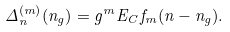Convert formula to latex. <formula><loc_0><loc_0><loc_500><loc_500>\Delta _ { n } ^ { ( m ) } ( n _ { g } ) = g ^ { m } E _ { C } f _ { m } ( n - n _ { g } ) .</formula> 